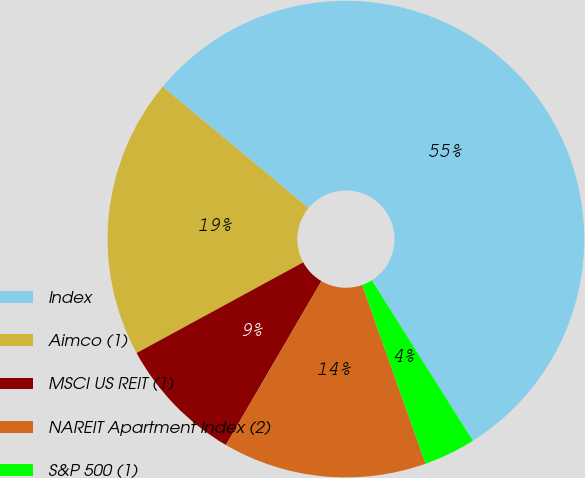Convert chart. <chart><loc_0><loc_0><loc_500><loc_500><pie_chart><fcel>Index<fcel>Aimco (1)<fcel>MSCI US REIT (1)<fcel>NAREIT Apartment Index (2)<fcel>S&P 500 (1)<nl><fcel>55.02%<fcel>18.97%<fcel>8.67%<fcel>13.82%<fcel>3.52%<nl></chart> 